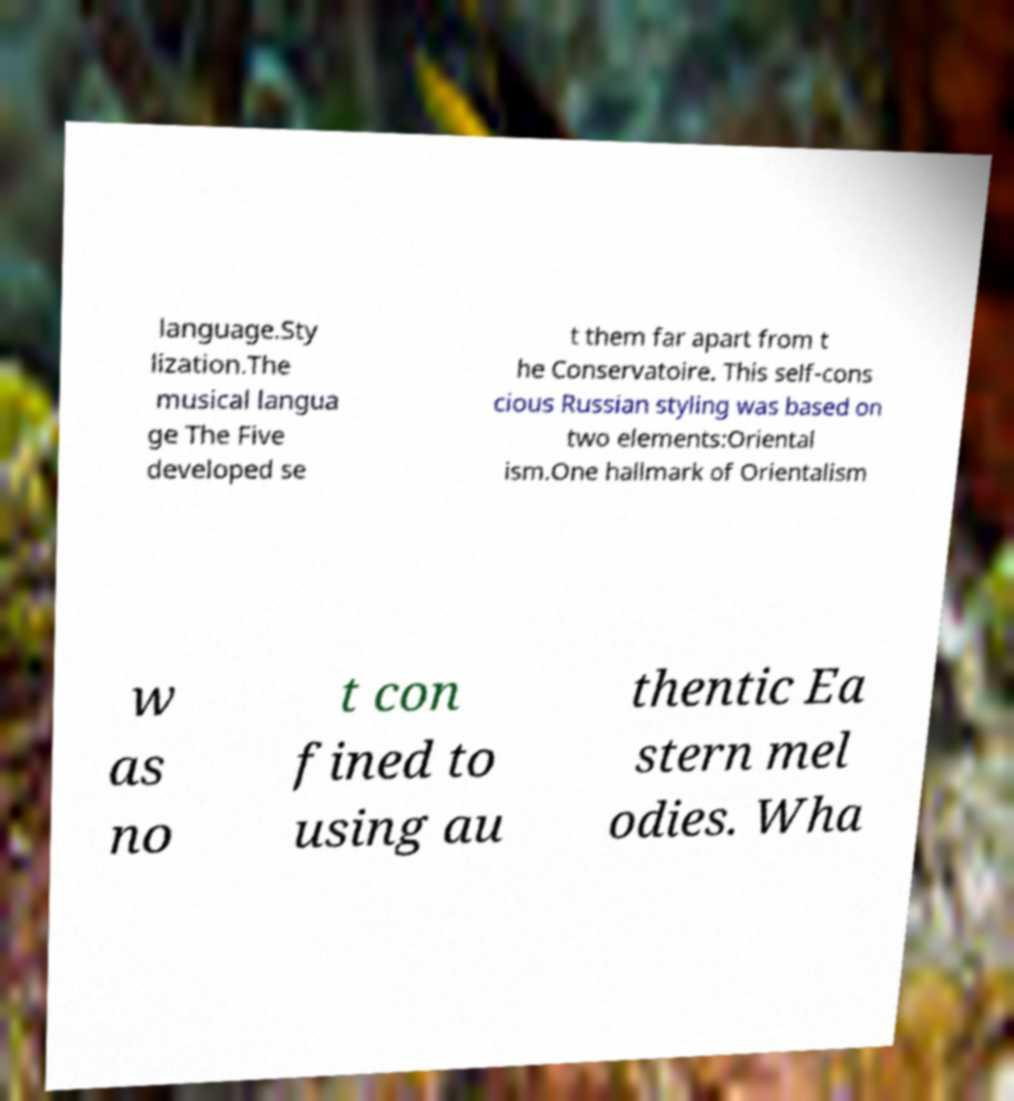Please identify and transcribe the text found in this image. language.Sty lization.The musical langua ge The Five developed se t them far apart from t he Conservatoire. This self-cons cious Russian styling was based on two elements:Oriental ism.One hallmark of Orientalism w as no t con fined to using au thentic Ea stern mel odies. Wha 